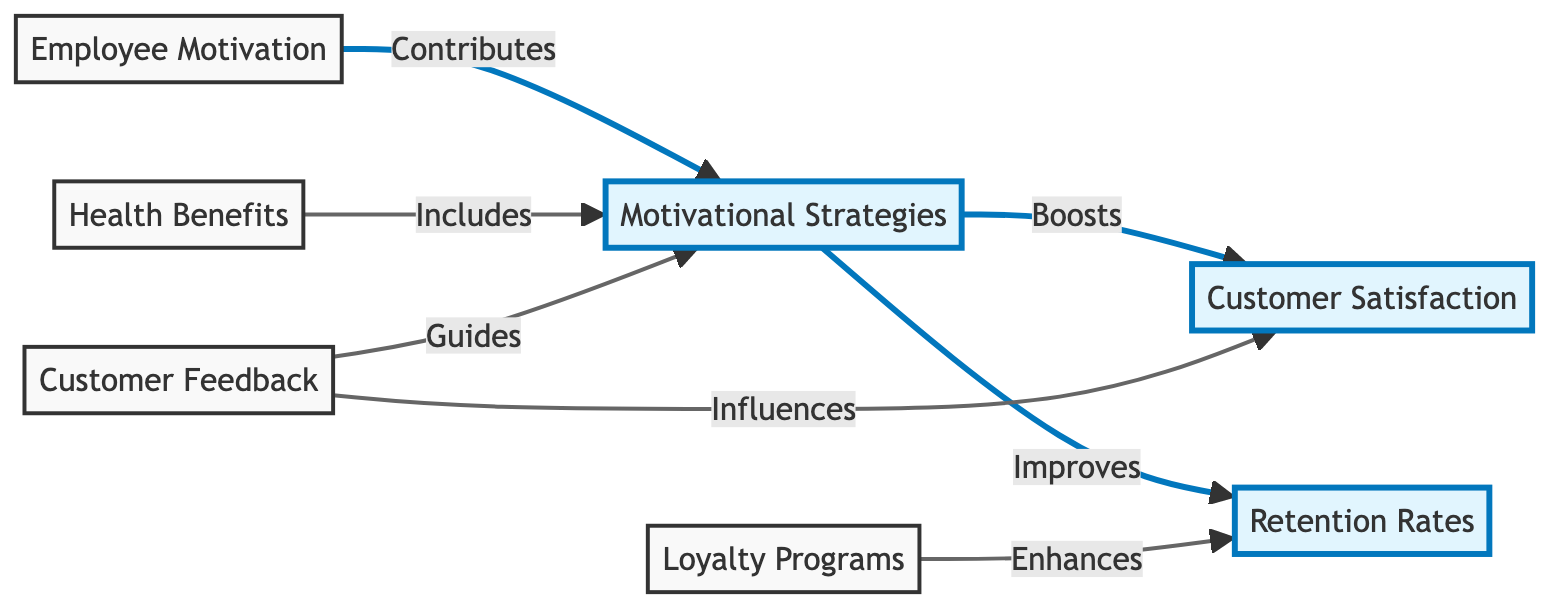What are the two highlighted nodes in the diagram? The diagram has two highlighted nodes, which are "Customer Satisfaction" and "Retention Rates." These are labeled distinctly in the diagram to show their importance.
Answer: Customer Satisfaction, Retention Rates How many main nodes are present in the diagram? The diagram consists of four main nodes: "Customer Satisfaction," "Retention Rates," "Motivational Strategies," and "Health Benefits." Counting these gives a total of four nodes.
Answer: Four What influences customer satisfaction according to the diagram? The diagram shows that "Customer Feedback" influences "Customer Satisfaction." This relationship indicates that feedback is a key factor in determining customer satisfaction.
Answer: Customer Feedback Which strategy enhances retention rates? The diagram indicates that "Loyalty Programs" enhance retention rates. This implies that implementing loyalty programs is beneficial for retaining customers.
Answer: Loyalty Programs What contributes to motivational strategies? According to the diagram, "Employee Motivation" contributes to "Motivational Strategies." This indicates that motivated employees are a basis for developing effective motivational strategies.
Answer: Employee Motivation How does customer feedback guide motivational strategies? The diagram shows that "Customer Feedback" guides "Motivational Strategies." This connection indicates that insights from customer feedback can shape and improve motivational strategies used in the store.
Answer: Guides What relationship exists between motivational strategies and customer satisfaction? The diagram states that "Motivational Strategies" boosts "Customer Satisfaction." This suggests that well-implemented motivational strategies can lead to higher satisfaction among customers.
Answer: Boosts Which node has a direct connection to both customer satisfaction and retention rates? The node "Motivational Strategies" has direct connections to both "Customer Satisfaction" and "Retention Rates." This shows that motivational strategies play a central role in impacting both aspects.
Answer: Motivational Strategies What guides motivational strategies? The diagram illustrates that "Customer Feedback" guides "Motivational Strategies," indicating that customer insights help inform how motivation is structured and implemented.
Answer: Customer Feedback 